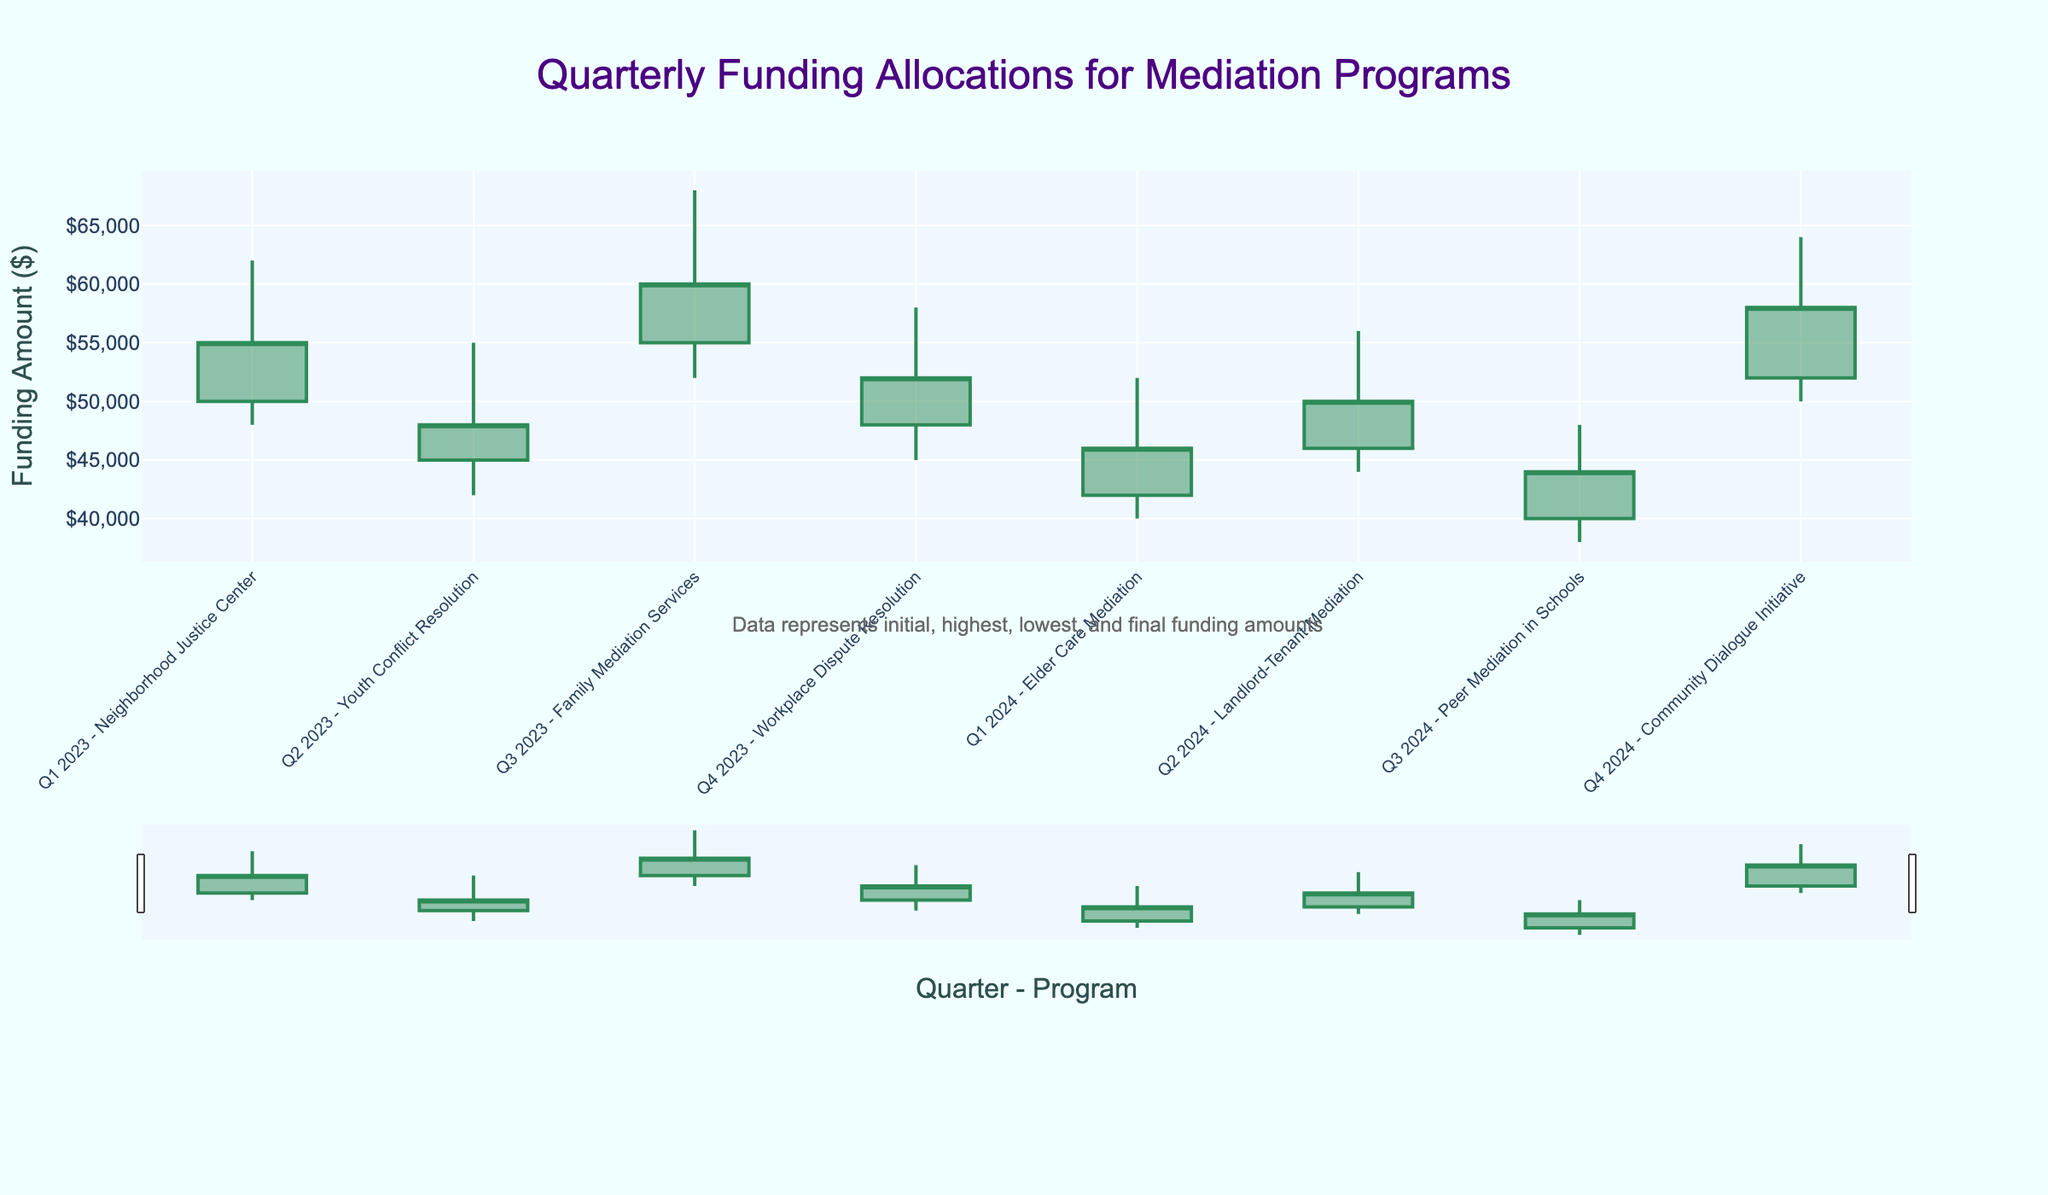What is the title of the figure? The title is typically located at the top of the figure. In this case, it reads "Quarterly Funding Allocations for Mediation Programs".
Answer: Quarterly Funding Allocations for Mediation Programs What is the initial funding amount for the Neighborhood Justice Center in Q1 2023? Look at the OHLC bar for "Q1 2023 - Neighborhood Justice Center" and identify the initial value. The initial value for the Neighborhood Justice Center is $50,000.
Answer: $50,000 Which program had the highest peak funding amount in Q2 2023? Compare the highest points for each program in Q2 2023. The highest peak for Q2 2023 is "Youth Conflict Resolution" with $55,000.
Answer: Youth Conflict Resolution What is the lowest funding amount across all programs and quarters shown? Scan the lowest points of all OHLC bars to find the minimum value. The lowest funding amount is $38,000 for "Peer Mediation in Schools" in Q3 2024.
Answer: $38,000 How much did the funding for Family Mediation Services increase from its lowest point to its final amount in Q3 2023? The lowest point for "Family Mediation Services" in Q3 2023 is $52,000, and the final amount is $60,000. The increase is $60,000 - $52,000 = $8,000.
Answer: $8,000 What is the average final amount of funding for all programs in 2023? Add the final amounts for all four quarters in 2023 ("Q1 2023 - $55,000", "Q2 2023 - $48,000", "Q3 2023 - $60,000", "Q4 2023 - $52,000") and divide by 4: (55,000 + 48,000 + 60,000 + 52,000) / 4 = $53,750.
Answer: $53,750 Which program had a decrease in funding from its initial to its final amount in Q4 2023? Check the initial and final amounts for each program in Q4 2023. "Workplace Dispute Resolution" had an initial amount of $48,000 and a final amount of $52,000, resulting in an increase, not a decrease.
Answer: None What is the difference between the highest and lowest funding amounts for the Community Dialogue Initiative in Q4 2024? For "Community Dialogue Initiative" in Q4 2024, the highest amount is $64,000 and the lowest is $50,000. The difference is $64,000 - $50,000 = $14,000.
Answer: $14,000 Which quarter and program had the smallest difference between the initial and final funding amounts? Calculate the difference between the initial and final amounts for each quarter and program. The smallest difference is for "Elder Care Mediation" in Q1 2024, with a difference of $46,000 - $42,000 = $4,000.
Answer: Q1 2024, Elder Care Mediation 